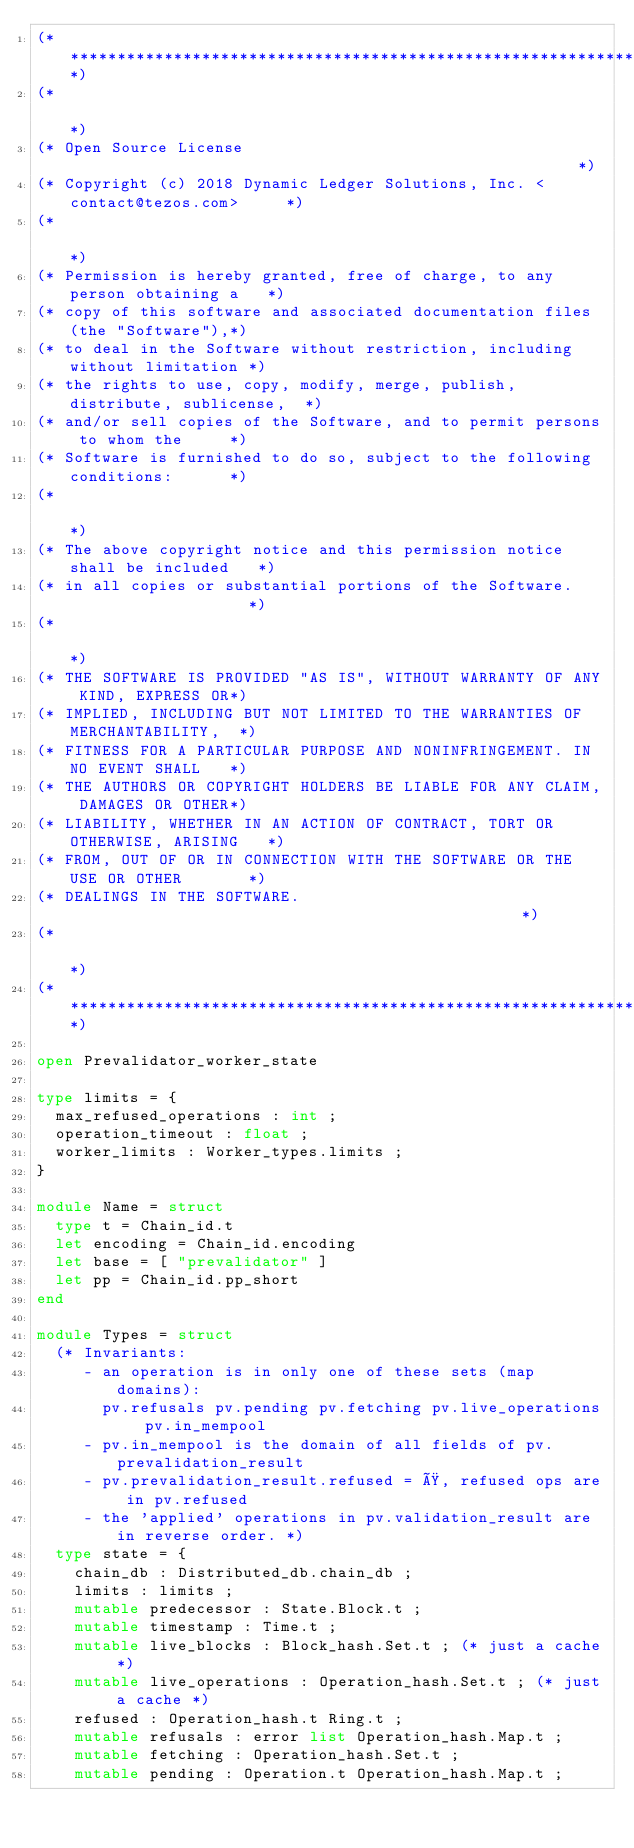<code> <loc_0><loc_0><loc_500><loc_500><_OCaml_>(*****************************************************************************)
(*                                                                           *)
(* Open Source License                                                       *)
(* Copyright (c) 2018 Dynamic Ledger Solutions, Inc. <contact@tezos.com>     *)
(*                                                                           *)
(* Permission is hereby granted, free of charge, to any person obtaining a   *)
(* copy of this software and associated documentation files (the "Software"),*)
(* to deal in the Software without restriction, including without limitation *)
(* the rights to use, copy, modify, merge, publish, distribute, sublicense,  *)
(* and/or sell copies of the Software, and to permit persons to whom the     *)
(* Software is furnished to do so, subject to the following conditions:      *)
(*                                                                           *)
(* The above copyright notice and this permission notice shall be included   *)
(* in all copies or substantial portions of the Software.                    *)
(*                                                                           *)
(* THE SOFTWARE IS PROVIDED "AS IS", WITHOUT WARRANTY OF ANY KIND, EXPRESS OR*)
(* IMPLIED, INCLUDING BUT NOT LIMITED TO THE WARRANTIES OF MERCHANTABILITY,  *)
(* FITNESS FOR A PARTICULAR PURPOSE AND NONINFRINGEMENT. IN NO EVENT SHALL   *)
(* THE AUTHORS OR COPYRIGHT HOLDERS BE LIABLE FOR ANY CLAIM, DAMAGES OR OTHER*)
(* LIABILITY, WHETHER IN AN ACTION OF CONTRACT, TORT OR OTHERWISE, ARISING   *)
(* FROM, OUT OF OR IN CONNECTION WITH THE SOFTWARE OR THE USE OR OTHER       *)
(* DEALINGS IN THE SOFTWARE.                                                 *)
(*                                                                           *)
(*****************************************************************************)

open Prevalidator_worker_state

type limits = {
  max_refused_operations : int ;
  operation_timeout : float ;
  worker_limits : Worker_types.limits ;
}

module Name = struct
  type t = Chain_id.t
  let encoding = Chain_id.encoding
  let base = [ "prevalidator" ]
  let pp = Chain_id.pp_short
end

module Types = struct
  (* Invariants:
     - an operation is in only one of these sets (map domains):
       pv.refusals pv.pending pv.fetching pv.live_operations pv.in_mempool
     - pv.in_mempool is the domain of all fields of pv.prevalidation_result
     - pv.prevalidation_result.refused = Ø, refused ops are in pv.refused
     - the 'applied' operations in pv.validation_result are in reverse order. *)
  type state = {
    chain_db : Distributed_db.chain_db ;
    limits : limits ;
    mutable predecessor : State.Block.t ;
    mutable timestamp : Time.t ;
    mutable live_blocks : Block_hash.Set.t ; (* just a cache *)
    mutable live_operations : Operation_hash.Set.t ; (* just a cache *)
    refused : Operation_hash.t Ring.t ;
    mutable refusals : error list Operation_hash.Map.t ;
    mutable fetching : Operation_hash.Set.t ;
    mutable pending : Operation.t Operation_hash.Map.t ;</code> 